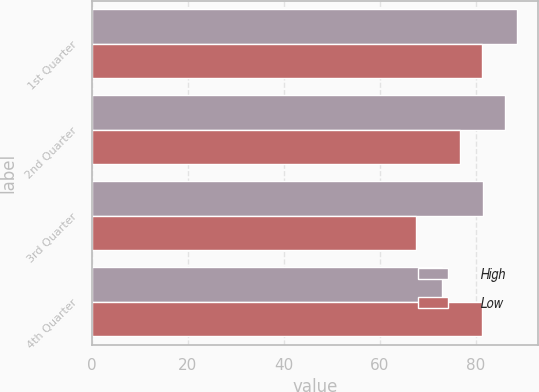Convert chart. <chart><loc_0><loc_0><loc_500><loc_500><stacked_bar_chart><ecel><fcel>1st Quarter<fcel>2nd Quarter<fcel>3rd Quarter<fcel>4th Quarter<nl><fcel>High<fcel>88.56<fcel>86<fcel>81.43<fcel>73<nl><fcel>Low<fcel>81.18<fcel>76.59<fcel>67.51<fcel>81.18<nl></chart> 